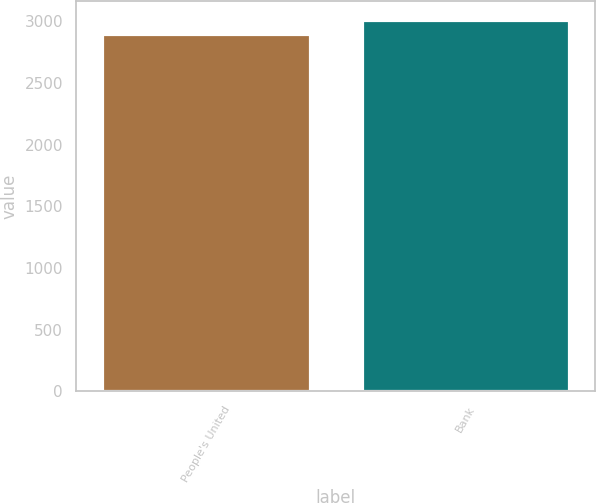Convert chart to OTSL. <chart><loc_0><loc_0><loc_500><loc_500><bar_chart><fcel>People's United<fcel>Bank<nl><fcel>2898.1<fcel>3012.7<nl></chart> 